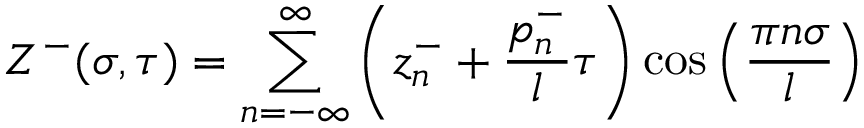Convert formula to latex. <formula><loc_0><loc_0><loc_500><loc_500>Z ^ { - } ( \sigma , \tau ) = \sum _ { n = - \infty } ^ { \infty } \left ( z _ { n } ^ { - } + \frac { p _ { n } ^ { - } } { l } \tau \right ) \cos \left ( \frac { \pi n \sigma } { l } \right )</formula> 